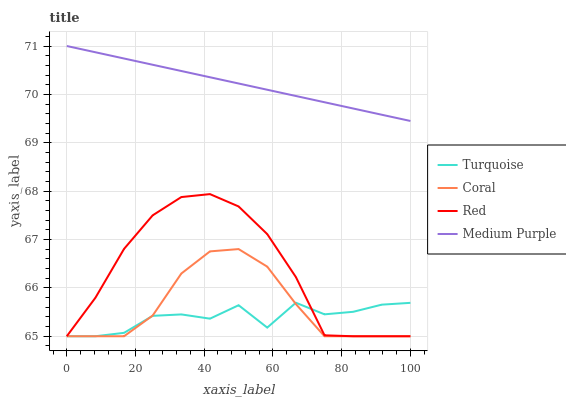Does Turquoise have the minimum area under the curve?
Answer yes or no. Yes. Does Medium Purple have the maximum area under the curve?
Answer yes or no. Yes. Does Coral have the minimum area under the curve?
Answer yes or no. No. Does Coral have the maximum area under the curve?
Answer yes or no. No. Is Medium Purple the smoothest?
Answer yes or no. Yes. Is Turquoise the roughest?
Answer yes or no. Yes. Is Coral the smoothest?
Answer yes or no. No. Is Coral the roughest?
Answer yes or no. No. Does Turquoise have the lowest value?
Answer yes or no. Yes. Does Medium Purple have the highest value?
Answer yes or no. Yes. Does Coral have the highest value?
Answer yes or no. No. Is Red less than Medium Purple?
Answer yes or no. Yes. Is Medium Purple greater than Turquoise?
Answer yes or no. Yes. Does Turquoise intersect Red?
Answer yes or no. Yes. Is Turquoise less than Red?
Answer yes or no. No. Is Turquoise greater than Red?
Answer yes or no. No. Does Red intersect Medium Purple?
Answer yes or no. No. 